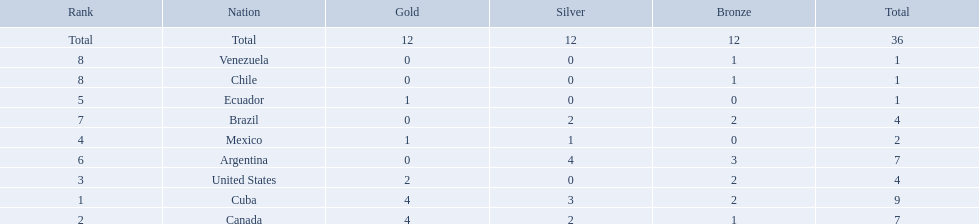What were the amounts of bronze medals won by the countries? 2, 1, 2, 0, 0, 3, 2, 1, 1. Which is the highest? 3. Which nation had this amount? Argentina. Which nations won a gold medal in canoeing in the 2011 pan american games? Cuba, Canada, United States, Mexico, Ecuador. Which of these did not win any silver medals? United States. Which countries have won gold medals? Cuba, Canada, United States, Mexico, Ecuador. Of these countries, which ones have never won silver or bronze medals? United States, Ecuador. Of the two nations listed previously, which one has only won a gold medal? Ecuador. Which countries won medals at the 2011 pan american games for the canoeing event? Cuba, Canada, United States, Mexico, Ecuador, Argentina, Brazil, Chile, Venezuela. Which of these countries won bronze medals? Cuba, Canada, United States, Argentina, Brazil, Chile, Venezuela. Of these countries, which won the most bronze medals? Argentina. Which nations competed in the 2011 pan american games? Cuba, Canada, United States, Mexico, Ecuador, Argentina, Brazil, Chile, Venezuela. Of these nations which ones won gold? Cuba, Canada, United States, Mexico, Ecuador. Which nation of the ones that won gold did not win silver? United States. 